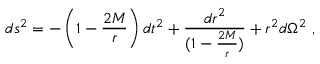Convert formula to latex. <formula><loc_0><loc_0><loc_500><loc_500>d s ^ { 2 } = - \left ( 1 - \frac { 2 M } { r } \right ) d t ^ { 2 } + { \frac { d r ^ { 2 } } { ( 1 - \frac { 2 M } { r } ) } } + r ^ { 2 } d \Omega ^ { 2 } \ ,</formula> 